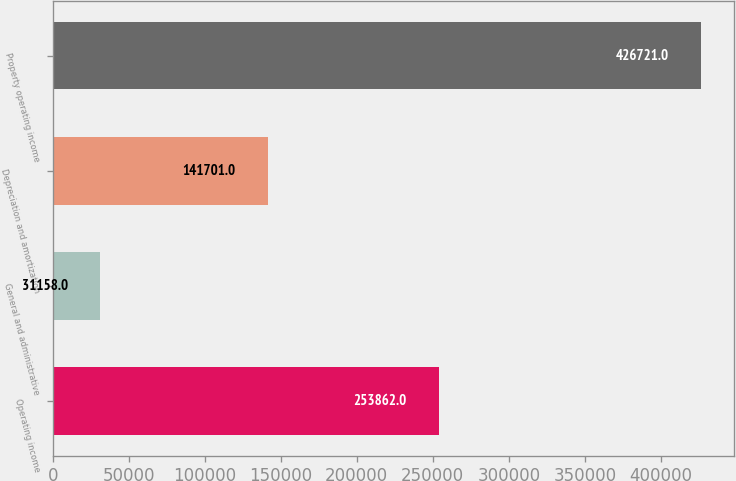<chart> <loc_0><loc_0><loc_500><loc_500><bar_chart><fcel>Operating income<fcel>General and administrative<fcel>Depreciation and amortization<fcel>Property operating income<nl><fcel>253862<fcel>31158<fcel>141701<fcel>426721<nl></chart> 